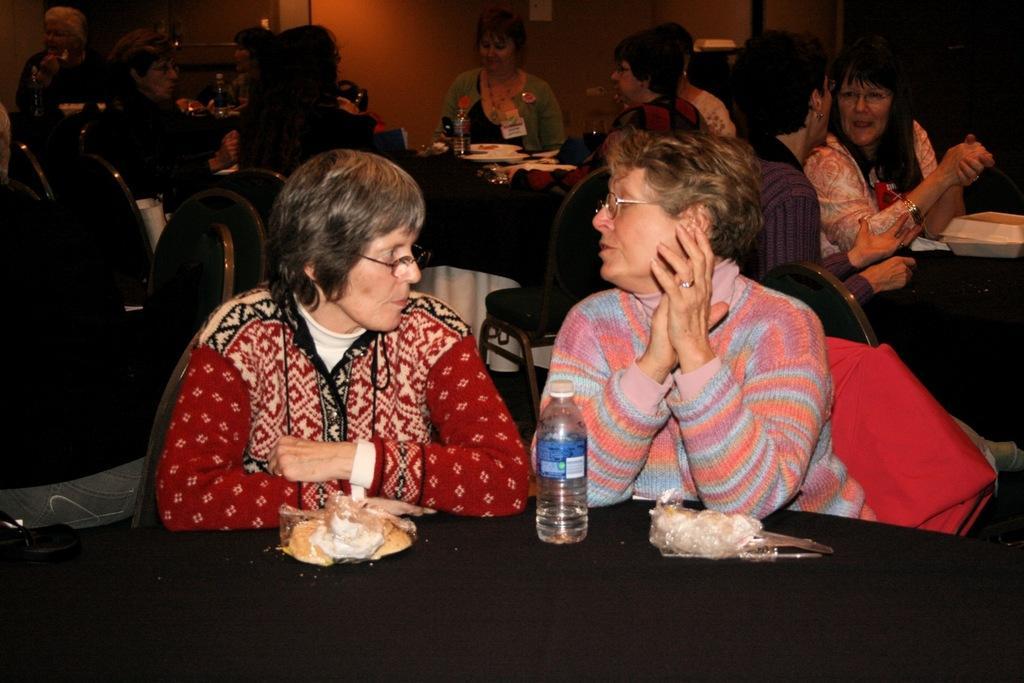How would you summarize this image in a sentence or two? In this picture we can see about a women wearing red color sweater sitting on the chair and discussing something with beside women wearing pink and blue sweater. In the front we can see black table top and which some snacks and water bottle is placed. Behind we can see other group of people sitting on the dining table eating and discussing something. 